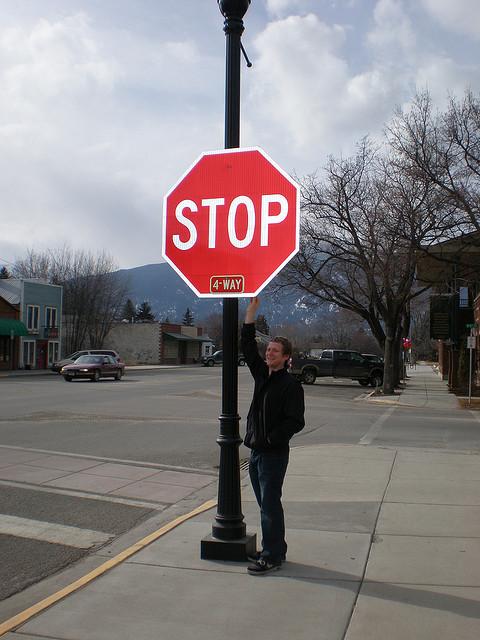What shape is the street sign facing away from the photographer?
Concise answer only. Octagon. Is the stop sign upside down?
Short answer required. No. Are the streets crowded?
Quick response, please. No. What does the sign with the black X represent?
Short answer required. Stop. Is the man touching the stop sign?
Answer briefly. Yes. What color is the man's shirt?
Concise answer only. Black. What kind of street sign is this?
Write a very short answer. Stop. What color are the trees?
Keep it brief. Brown. What street does the sign say?
Short answer required. Stop. Is that stop sign unusually large?
Give a very brief answer. Yes. 